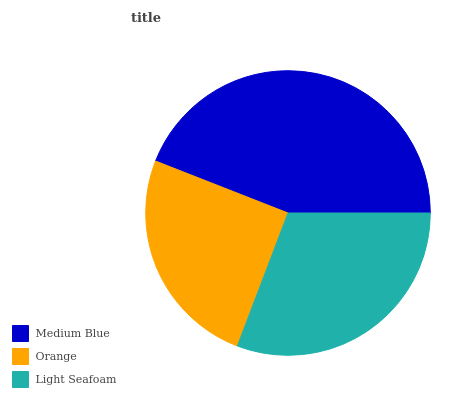Is Orange the minimum?
Answer yes or no. Yes. Is Medium Blue the maximum?
Answer yes or no. Yes. Is Light Seafoam the minimum?
Answer yes or no. No. Is Light Seafoam the maximum?
Answer yes or no. No. Is Light Seafoam greater than Orange?
Answer yes or no. Yes. Is Orange less than Light Seafoam?
Answer yes or no. Yes. Is Orange greater than Light Seafoam?
Answer yes or no. No. Is Light Seafoam less than Orange?
Answer yes or no. No. Is Light Seafoam the high median?
Answer yes or no. Yes. Is Light Seafoam the low median?
Answer yes or no. Yes. Is Medium Blue the high median?
Answer yes or no. No. Is Medium Blue the low median?
Answer yes or no. No. 